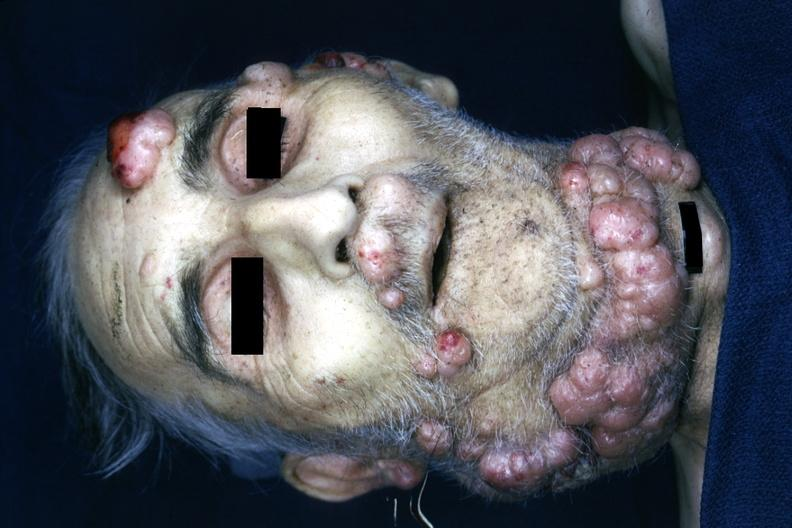s face present?
Answer the question using a single word or phrase. Yes 